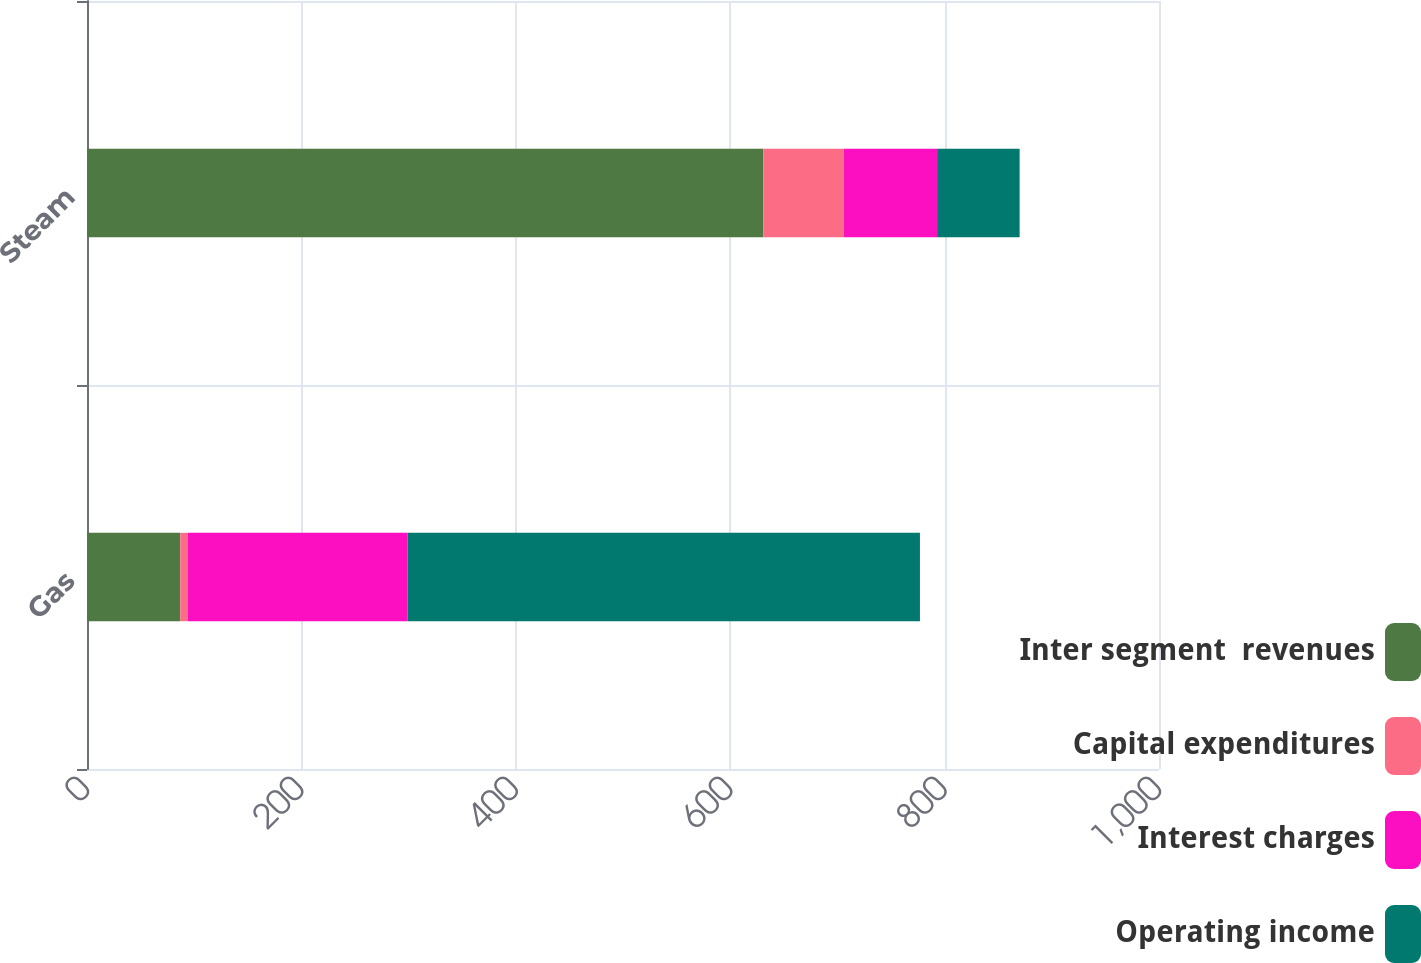Convert chart. <chart><loc_0><loc_0><loc_500><loc_500><stacked_bar_chart><ecel><fcel>Gas<fcel>Steam<nl><fcel>Inter segment  revenues<fcel>87<fcel>631<nl><fcel>Capital expenditures<fcel>7<fcel>75<nl><fcel>Interest charges<fcel>205<fcel>87<nl><fcel>Operating income<fcel>478<fcel>77<nl></chart> 